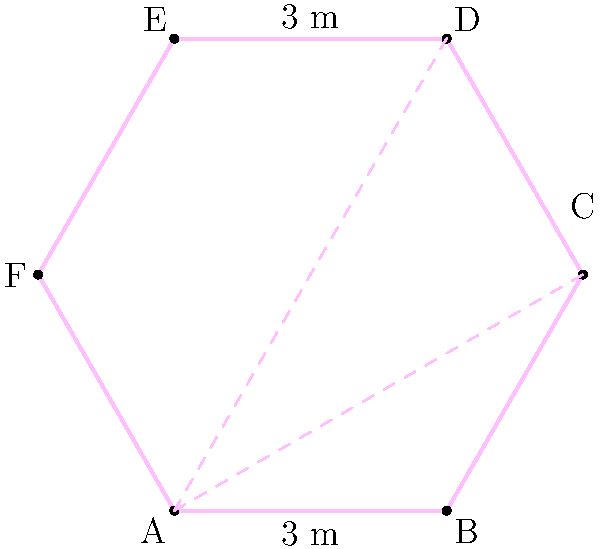Your adorable Chihuahua's favorite pink hexagonal dog park needs a new fence. The park has 6 equal sides, and you know that the distance between opposite corners (e.g., from A to D) is 8 meters. What is the total length of fencing needed to enclose the entire park? Let's approach this step-by-step:

1) In a regular hexagon, the distance between opposite corners is called the diameter. It's equal to twice the side length. So if AD = 8 m, then each side of the hexagon is 4 m.

2) The perimeter of a regular hexagon is the sum of all its sides. Since there are 6 equal sides, we can multiply the side length by 6:

   Perimeter = $6 \times$ side length
              = $6 \times 4$ m
              = 24 m

3) Therefore, the total length of fencing needed is 24 meters.

Note: This problem utilizes the properties of regular hexagons, which have all sides equal and all angles equal to 120°. The pink dashed lines in the diagram represent the diameter of the hexagon, which is twice the side length.
Answer: 24 m 